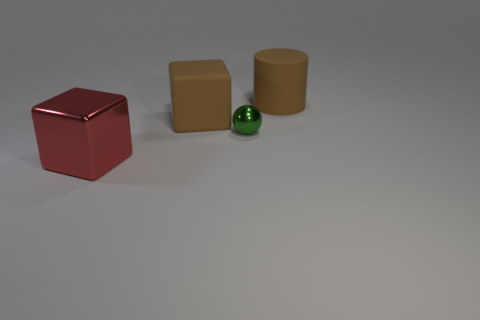Is the size of the rubber cylinder the same as the shiny cube?
Your answer should be very brief. Yes. The small shiny object has what color?
Provide a short and direct response. Green. What number of objects are either large yellow matte spheres or large brown matte cylinders?
Offer a terse response. 1. Is there another green metallic object that has the same shape as the small green metallic thing?
Your response must be concise. No. There is a big rubber object in front of the brown matte cylinder; does it have the same color as the tiny object?
Make the answer very short. No. There is a shiny thing behind the block in front of the small green metal thing; what is its shape?
Make the answer very short. Sphere. Is there a brown matte thing of the same size as the rubber block?
Your answer should be very brief. Yes. Is the number of big brown matte cylinders less than the number of rubber objects?
Ensure brevity in your answer.  Yes. What is the shape of the thing left of the rubber thing that is on the left side of the brown rubber object to the right of the green metallic thing?
Provide a short and direct response. Cube. How many things are either brown objects to the right of the tiny shiny sphere or big objects behind the large matte block?
Provide a succinct answer. 1. 